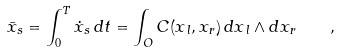Convert formula to latex. <formula><loc_0><loc_0><loc_500><loc_500>\bar { x } _ { s } = \int _ { 0 } ^ { T } \dot { x } _ { s } \, { d } t = \int _ { O } C ( x _ { \, l } , x _ { r } ) \, { d } x _ { \, l } \wedge { d } x _ { r } \quad ,</formula> 